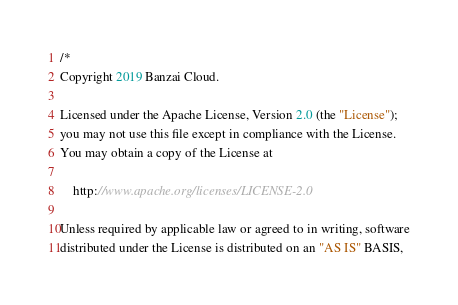<code> <loc_0><loc_0><loc_500><loc_500><_Go_>/*
Copyright 2019 Banzai Cloud.

Licensed under the Apache License, Version 2.0 (the "License");
you may not use this file except in compliance with the License.
You may obtain a copy of the License at

    http://www.apache.org/licenses/LICENSE-2.0

Unless required by applicable law or agreed to in writing, software
distributed under the License is distributed on an "AS IS" BASIS,</code> 